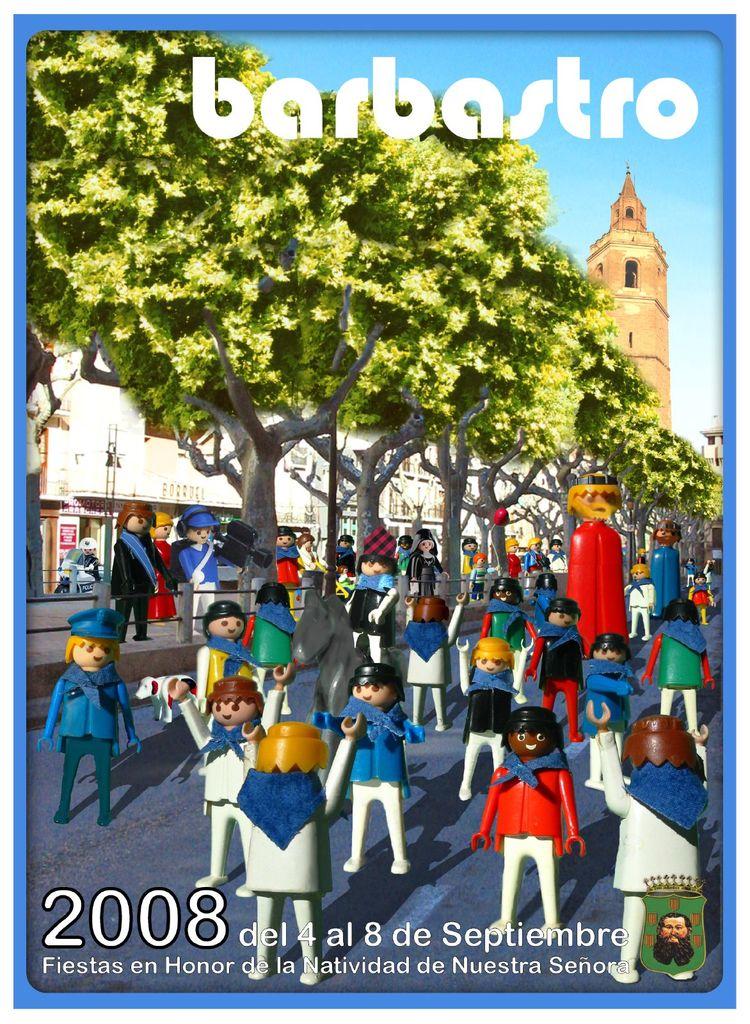What year is this event?
Keep it short and to the point. 2008. What is the name of this event?
Make the answer very short. Barbastro. 